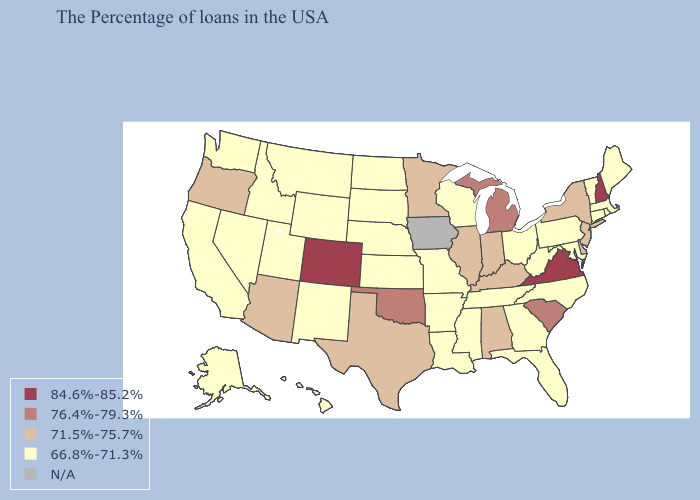Does Oklahoma have the lowest value in the USA?
Short answer required. No. Which states have the lowest value in the USA?
Answer briefly. Maine, Massachusetts, Rhode Island, Vermont, Connecticut, Maryland, Pennsylvania, North Carolina, West Virginia, Ohio, Florida, Georgia, Tennessee, Wisconsin, Mississippi, Louisiana, Missouri, Arkansas, Kansas, Nebraska, South Dakota, North Dakota, Wyoming, New Mexico, Utah, Montana, Idaho, Nevada, California, Washington, Alaska, Hawaii. Among the states that border Georgia , which have the lowest value?
Keep it brief. North Carolina, Florida, Tennessee. Does Washington have the highest value in the USA?
Be succinct. No. Among the states that border Kentucky , does Virginia have the lowest value?
Keep it brief. No. Does Virginia have the highest value in the USA?
Short answer required. Yes. What is the lowest value in the USA?
Give a very brief answer. 66.8%-71.3%. Name the states that have a value in the range N/A?
Be succinct. Iowa. Name the states that have a value in the range 84.6%-85.2%?
Write a very short answer. New Hampshire, Virginia, Colorado. What is the value of Vermont?
Write a very short answer. 66.8%-71.3%. Name the states that have a value in the range 76.4%-79.3%?
Short answer required. South Carolina, Michigan, Oklahoma. How many symbols are there in the legend?
Be succinct. 5. 